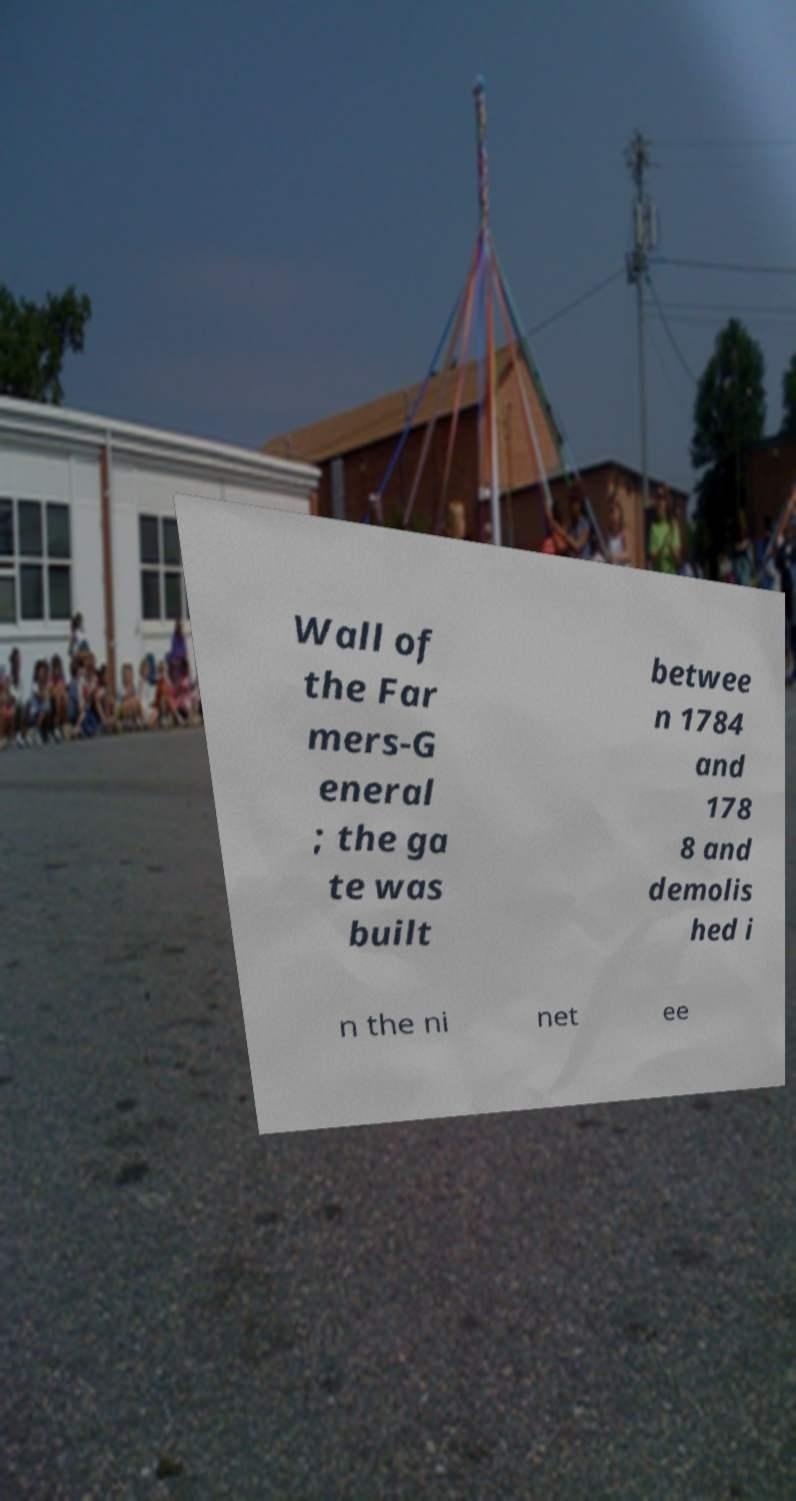I need the written content from this picture converted into text. Can you do that? Wall of the Far mers-G eneral ; the ga te was built betwee n 1784 and 178 8 and demolis hed i n the ni net ee 